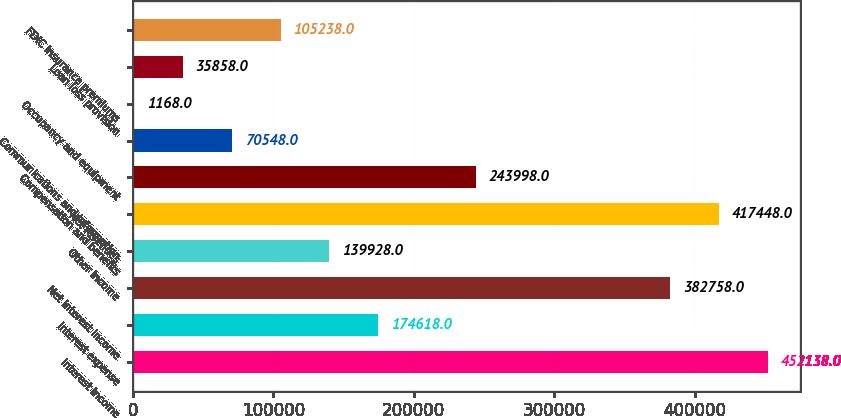Convert chart. <chart><loc_0><loc_0><loc_500><loc_500><bar_chart><fcel>Interest income<fcel>Interest expense<fcel>Net interest income<fcel>Other income<fcel>Net revenues<fcel>Compensation and benefits<fcel>Communications and information<fcel>Occupancy and equipment<fcel>Loan loss provision<fcel>FDIC insurance premiums<nl><fcel>452138<fcel>174618<fcel>382758<fcel>139928<fcel>417448<fcel>243998<fcel>70548<fcel>1168<fcel>35858<fcel>105238<nl></chart> 